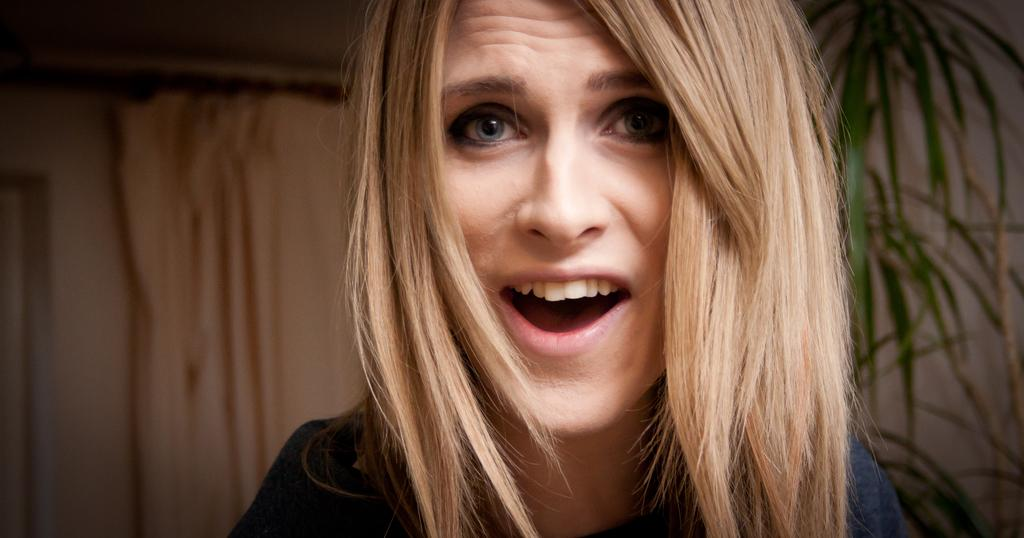What can be observed about the background of the image? The background portion of the picture is blurry. What type of object is present in the image? There is a curtain in the image. What other living organism can be seen in the image? There is a plant in the image. Who is the main subject of the image? The main subject of the image is a woman. How many trees are visible in the image? There are no trees visible in the image. What type of voyage is the woman embarking on in the image? There is no indication of a voyage in the image; it simply features a woman, a curtain, and a plant. 